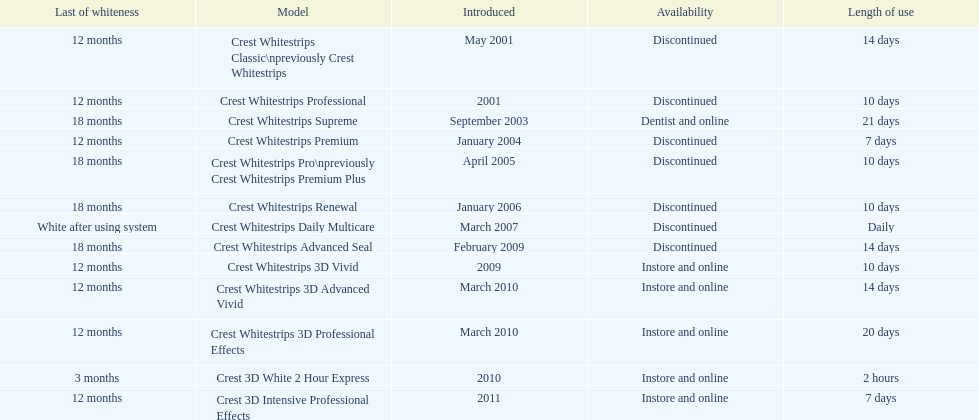Is each white strip discontinued? No. 